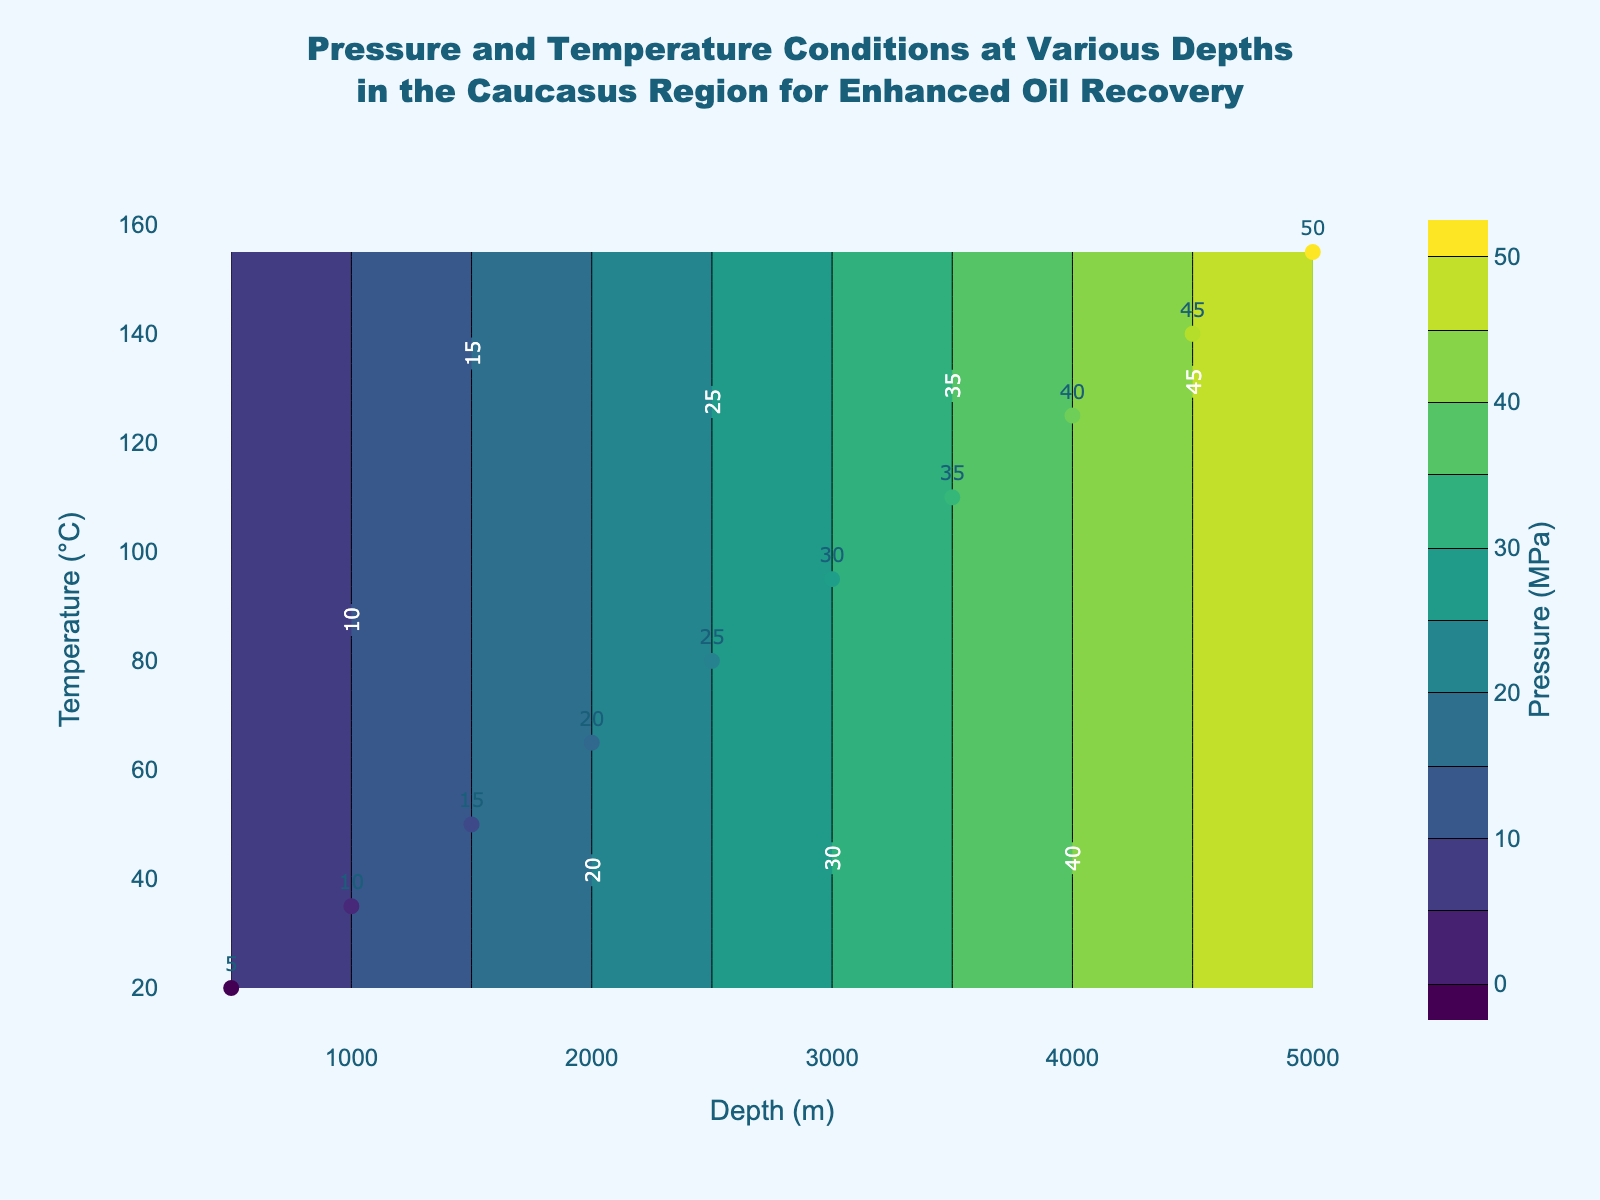What's the title of the plot? The title is centered at the top of the plot. It reads "Pressure and Temperature Conditions at Various Depths in the Caucasus Region for Enhanced Oil Recovery".
Answer: Pressure and Temperature Conditions at Various Depths in the Caucasus Region for Enhanced Oil Recovery What is the pressure at a depth of 3000 meters? The pressure values are indicated by both scatter plot labels and contour lines. At the depth of 3000 meters, the label shows a pressure of 30 MPa.
Answer: 30 MPa What is the temperature corresponding to a depth of 4500 meters? The scatter plot points represent specific depth-temperature-pressure triplets. At 4500 meters depth, the temperature is indicated to be 140°C.
Answer: 140°C Describe the trend of pressure with increasing depth. As depth increases, the pressure values increase linearly from 5 MPa at 500 meters to 50 MPa at 5000 meters, showing a direct relationship between depth and pressure.
Answer: Linear increase Compare the temperature at 2000 meters depth with the temperature at 3500 meters depth. Which one is higher and by how much? At 2000 meters the temperature is 65°C, and at 3500 meters it is 110°C. The difference is calculated as 110°C - 65°C.
Answer: 3500 meters is higher by 45°C What is the pressure difference between the shallowest and deepest depths? The shallowest depth is 500 meters with a pressure of 5 MPa, and the deepest depth is 5000 meters with a pressure of 50 MPa. The difference is 50 MPa - 5 MPa.
Answer: 45 MPa How does the color scale help in interpreting the pressure values across the plot? The color scale on the right indicates pressure values in MPa ranging from 0 to 50. Different shades of the 'Viridis' color scale represent different pressures, making it easier to visualize pressure changes.
Answer: Shows pressure levels in MPa Are there any visible outliers in the pressure data based on the scatter plot points? All scatter plot points align well with contour lines indicating consistent pressure trends. There are no points that deviate significantly from the general pattern.
Answer: No What are the contour intervals used in the plot? The contour intervals are specified by the step size between contours. Each contour line represents a 5 MPa increment.
Answer: 5 MPa What temperature corresponds to a depth of 2500 meters and a pressure of 25 MPa? Checking the scatter plot labels shows that at 2500 meters, the temperature is 80°C, correlating with a pressure of 25 MPa.
Answer: 80°C 